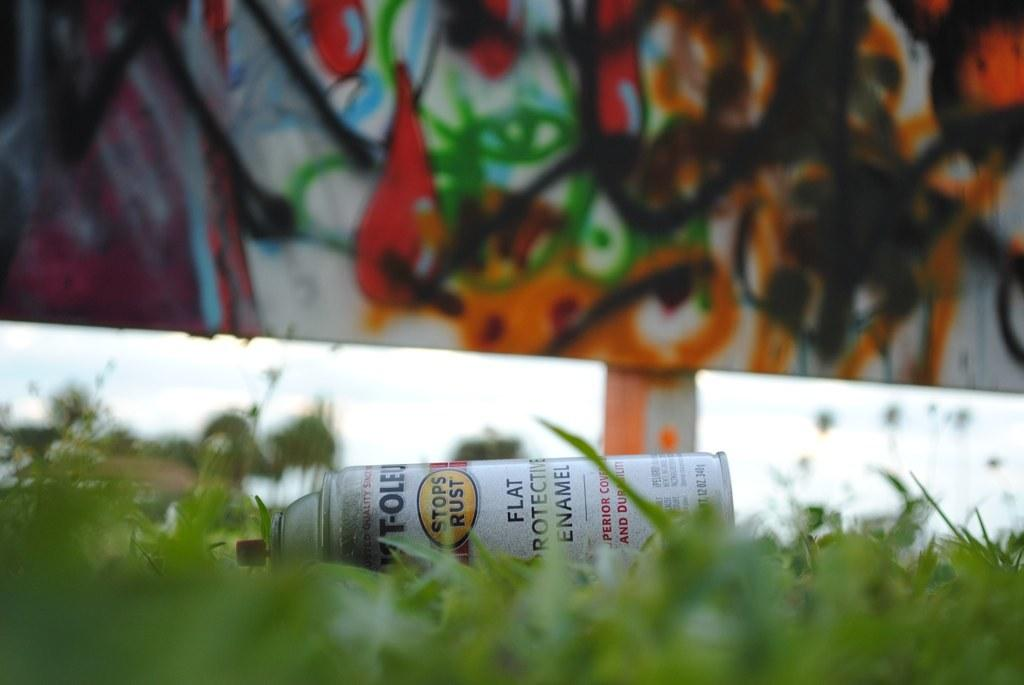<image>
Present a compact description of the photo's key features. Can of flat protector enamel laying in the grass 